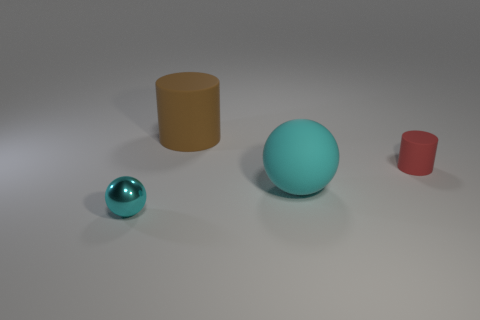How many big objects are either brown metal cylinders or cyan metallic spheres?
Ensure brevity in your answer.  0. What is the material of the ball that is the same color as the small metal thing?
Your answer should be very brief. Rubber. Are there fewer tiny cylinders than big things?
Make the answer very short. Yes. There is a cyan object right of the small cyan metallic ball; is its size the same as the ball on the left side of the big cylinder?
Keep it short and to the point. No. What number of purple objects are either metallic things or metallic cylinders?
Your response must be concise. 0. There is another ball that is the same color as the large sphere; what is its size?
Offer a terse response. Small. Are there more big cyan things than tiny yellow balls?
Give a very brief answer. Yes. Is the tiny ball the same color as the big sphere?
Keep it short and to the point. Yes. How many things are either cyan metal spheres or rubber things that are right of the large rubber cylinder?
Keep it short and to the point. 3. What number of other things are there of the same shape as the big cyan object?
Provide a short and direct response. 1. 